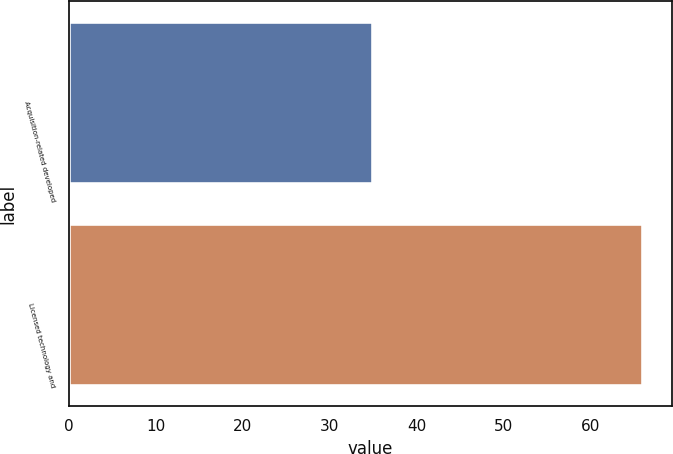Convert chart to OTSL. <chart><loc_0><loc_0><loc_500><loc_500><bar_chart><fcel>Acquisition-related developed<fcel>Licensed technology and<nl><fcel>35<fcel>66<nl></chart> 